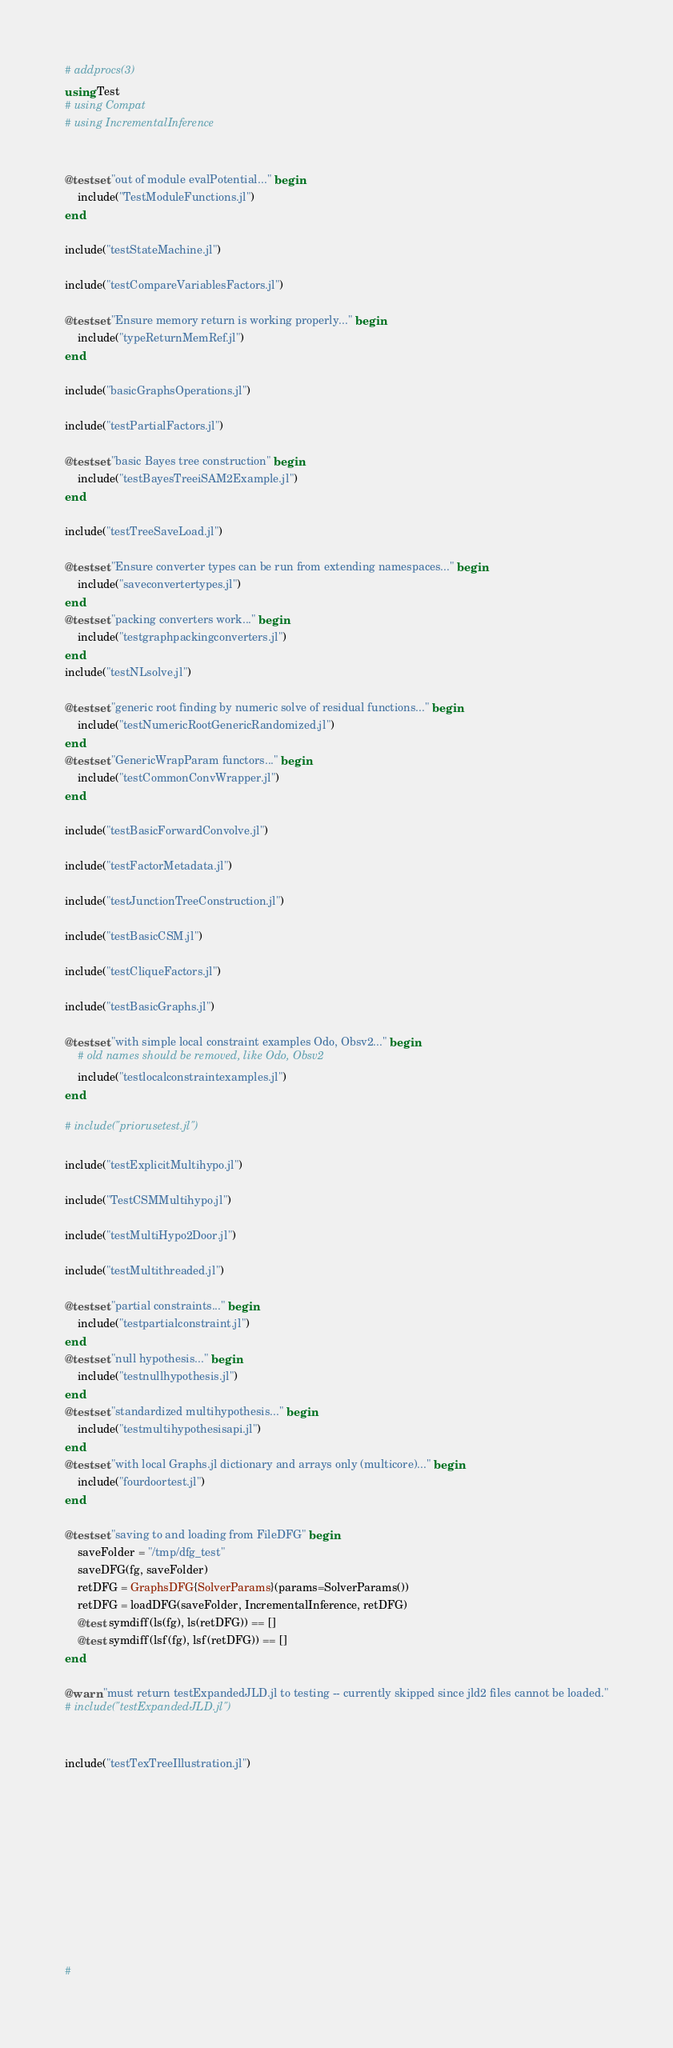Convert code to text. <code><loc_0><loc_0><loc_500><loc_500><_Julia_># addprocs(3)
using Test
# using Compat
# using IncrementalInference


@testset "out of module evalPotential..." begin
    include("TestModuleFunctions.jl")
end

include("testStateMachine.jl")

include("testCompareVariablesFactors.jl")

@testset "Ensure memory return is working properly..." begin
    include("typeReturnMemRef.jl")
end

include("basicGraphsOperations.jl")

include("testPartialFactors.jl")

@testset "basic Bayes tree construction" begin
    include("testBayesTreeiSAM2Example.jl")
end

include("testTreeSaveLoad.jl")

@testset "Ensure converter types can be run from extending namespaces..." begin
    include("saveconvertertypes.jl")
end
@testset "packing converters work..." begin
    include("testgraphpackingconverters.jl")
end
include("testNLsolve.jl")

@testset "generic root finding by numeric solve of residual functions..." begin
    include("testNumericRootGenericRandomized.jl")
end
@testset "GenericWrapParam functors..." begin
    include("testCommonConvWrapper.jl")
end

include("testBasicForwardConvolve.jl")

include("testFactorMetadata.jl")

include("testJunctionTreeConstruction.jl")

include("testBasicCSM.jl")

include("testCliqueFactors.jl")

include("testBasicGraphs.jl")

@testset "with simple local constraint examples Odo, Obsv2..." begin
    # old names should be removed, like Odo, Obsv2
    include("testlocalconstraintexamples.jl")
end

# include("priorusetest.jl")

include("testExplicitMultihypo.jl")

include("TestCSMMultihypo.jl")

include("testMultiHypo2Door.jl")

include("testMultithreaded.jl")

@testset "partial constraints..." begin
    include("testpartialconstraint.jl")
end
@testset "null hypothesis..." begin
    include("testnullhypothesis.jl")
end
@testset "standardized multihypothesis..." begin
    include("testmultihypothesisapi.jl")
end
@testset "with local Graphs.jl dictionary and arrays only (multicore)..." begin
    include("fourdoortest.jl")
end

@testset "saving to and loading from FileDFG" begin
    saveFolder = "/tmp/dfg_test"
    saveDFG(fg, saveFolder)
    retDFG = GraphsDFG{SolverParams}(params=SolverParams())
    retDFG = loadDFG(saveFolder, IncrementalInference, retDFG)
    @test symdiff(ls(fg), ls(retDFG)) == []
    @test symdiff(lsf(fg), lsf(retDFG)) == []
end

@warn "must return testExpandedJLD.jl to testing -- currently skipped since jld2 files cannot be loaded."
# include("testExpandedJLD.jl")


include("testTexTreeIllustration.jl")











#
</code> 